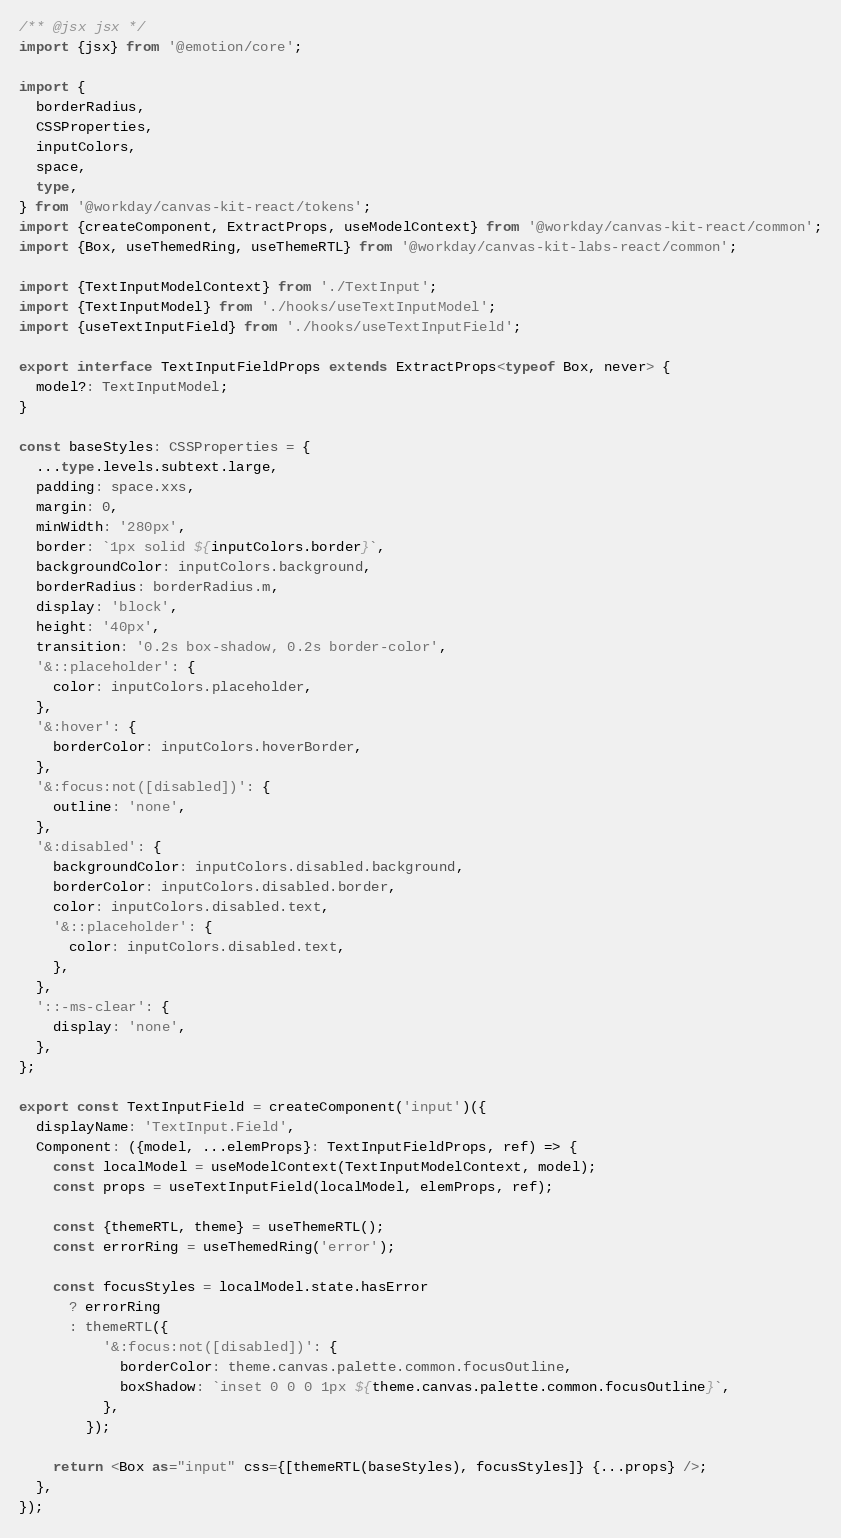Convert code to text. <code><loc_0><loc_0><loc_500><loc_500><_TypeScript_>/** @jsx jsx */
import {jsx} from '@emotion/core';

import {
  borderRadius,
  CSSProperties,
  inputColors,
  space,
  type,
} from '@workday/canvas-kit-react/tokens';
import {createComponent, ExtractProps, useModelContext} from '@workday/canvas-kit-react/common';
import {Box, useThemedRing, useThemeRTL} from '@workday/canvas-kit-labs-react/common';

import {TextInputModelContext} from './TextInput';
import {TextInputModel} from './hooks/useTextInputModel';
import {useTextInputField} from './hooks/useTextInputField';

export interface TextInputFieldProps extends ExtractProps<typeof Box, never> {
  model?: TextInputModel;
}

const baseStyles: CSSProperties = {
  ...type.levels.subtext.large,
  padding: space.xxs,
  margin: 0,
  minWidth: '280px',
  border: `1px solid ${inputColors.border}`,
  backgroundColor: inputColors.background,
  borderRadius: borderRadius.m,
  display: 'block',
  height: '40px',
  transition: '0.2s box-shadow, 0.2s border-color',
  '&::placeholder': {
    color: inputColors.placeholder,
  },
  '&:hover': {
    borderColor: inputColors.hoverBorder,
  },
  '&:focus:not([disabled])': {
    outline: 'none',
  },
  '&:disabled': {
    backgroundColor: inputColors.disabled.background,
    borderColor: inputColors.disabled.border,
    color: inputColors.disabled.text,
    '&::placeholder': {
      color: inputColors.disabled.text,
    },
  },
  '::-ms-clear': {
    display: 'none',
  },
};

export const TextInputField = createComponent('input')({
  displayName: 'TextInput.Field',
  Component: ({model, ...elemProps}: TextInputFieldProps, ref) => {
    const localModel = useModelContext(TextInputModelContext, model);
    const props = useTextInputField(localModel, elemProps, ref);

    const {themeRTL, theme} = useThemeRTL();
    const errorRing = useThemedRing('error');

    const focusStyles = localModel.state.hasError
      ? errorRing
      : themeRTL({
          '&:focus:not([disabled])': {
            borderColor: theme.canvas.palette.common.focusOutline,
            boxShadow: `inset 0 0 0 1px ${theme.canvas.palette.common.focusOutline}`,
          },
        });

    return <Box as="input" css={[themeRTL(baseStyles), focusStyles]} {...props} />;
  },
});
</code> 